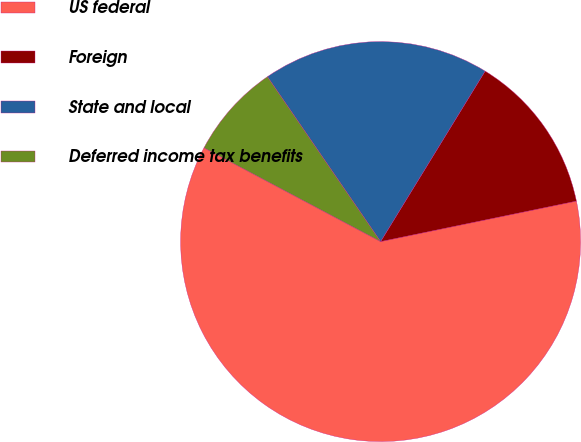Convert chart to OTSL. <chart><loc_0><loc_0><loc_500><loc_500><pie_chart><fcel>US federal<fcel>Foreign<fcel>State and local<fcel>Deferred income tax benefits<nl><fcel>61.01%<fcel>13.0%<fcel>18.33%<fcel>7.66%<nl></chart> 